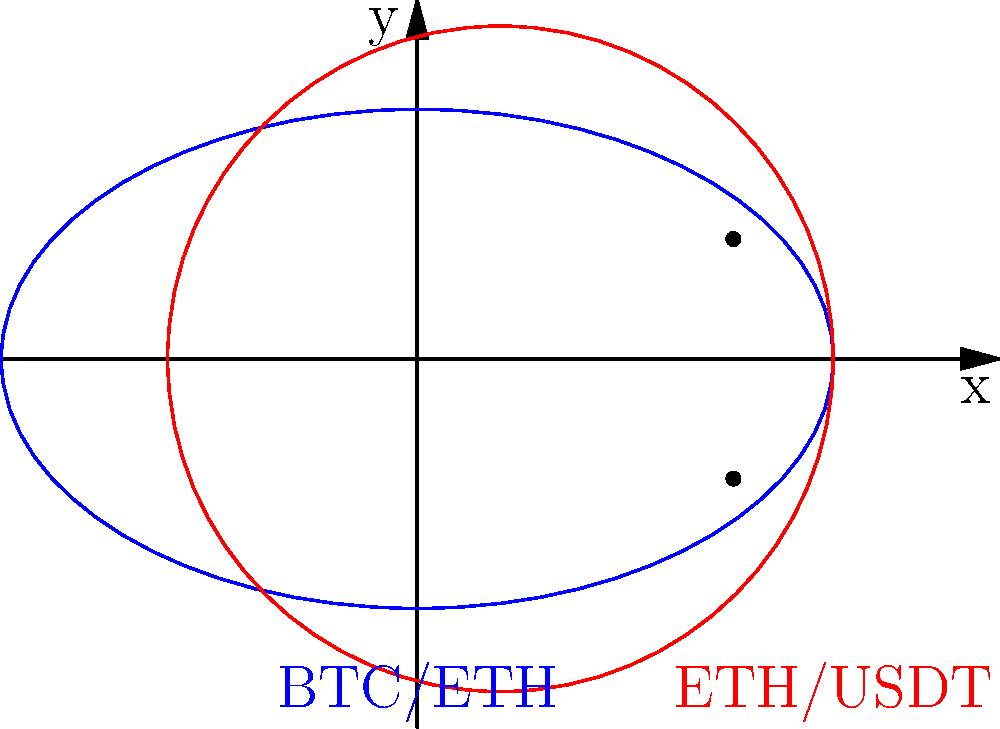In our decentralized exchange, two popular trading pairs are represented by ellipses on a graph: BTC/ETH (blue) and ETH/USDT (red). The BTC/ETH ellipse is centered at the origin with semi-major axis $a_1=5$ and semi-minor axis $b_1=3$. The ETH/USDT ellipse is centered at $(1,0)$ with semi-major axis $a_2=4$ and semi-minor axis $b_2=4$. Find the x-coordinate of the intersection points of these two ellipses, which represent potential arbitrage opportunities. Let's approach this step-by-step:

1) The equation of the BTC/ETH ellipse (centered at origin) is:
   $$\frac{x^2}{25} + \frac{y^2}{9} = 1$$

2) The equation of the ETH/USDT ellipse (centered at (1,0)) is:
   $$\frac{(x-1)^2}{16} + \frac{y^2}{16} = 1$$

3) To find the intersection points, we need to solve these equations simultaneously. Let's start by rearranging the second equation:
   $$\frac{x^2-2x+1}{16} + \frac{y^2}{16} = 1$$
   $$x^2-2x+1 + y^2 = 16$$
   $$y^2 = 15 - x^2 + 2x$$

4) Substitute this expression for $y^2$ into the first equation:
   $$\frac{x^2}{25} + \frac{15 - x^2 + 2x}{9} = 1$$

5) Multiply both sides by 225:
   $$9x^2 + 25(15 - x^2 + 2x) = 225$$

6) Expand:
   $$9x^2 + 375 - 25x^2 + 50x = 225$$

7) Rearrange:
   $$-16x^2 + 50x + 150 = 0$$

8) Divide by -2:
   $$8x^2 - 25x - 75 = 0$$

9) This is a quadratic equation. We can solve it using the quadratic formula:
   $$x = \frac{-b \pm \sqrt{b^2 - 4ac}}{2a}$$
   where $a=8$, $b=-25$, and $c=-75$

10) Plugging in these values:
    $$x = \frac{25 \pm \sqrt{625 + 2400}}{16} = \frac{25 \pm \sqrt{3025}}{16} = \frac{25 \pm 55}{16}$$

11) This gives us two solutions:
    $$x = \frac{25 + 55}{16} = \frac{80}{16} = 5$$ or $$x = \frac{25 - 55}{16} = -\frac{30}{16} = -1.875$$

12) However, looking at the graph, we can see that the intersection points have x-coordinates between 3 and 4. The solution $x=5$ is outside this range, so we discard it.

Therefore, the x-coordinate of the intersection points is $x = 3.8125$ or approximately 3.8.
Answer: $x \approx 3.8$ 